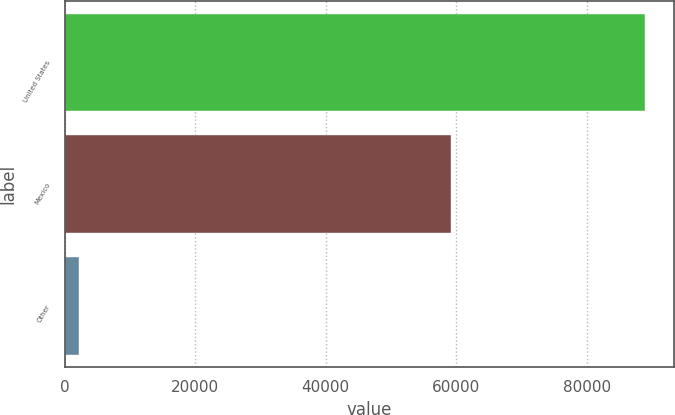Convert chart. <chart><loc_0><loc_0><loc_500><loc_500><bar_chart><fcel>United States<fcel>Mexico<fcel>Other<nl><fcel>88896<fcel>59234<fcel>2253<nl></chart> 